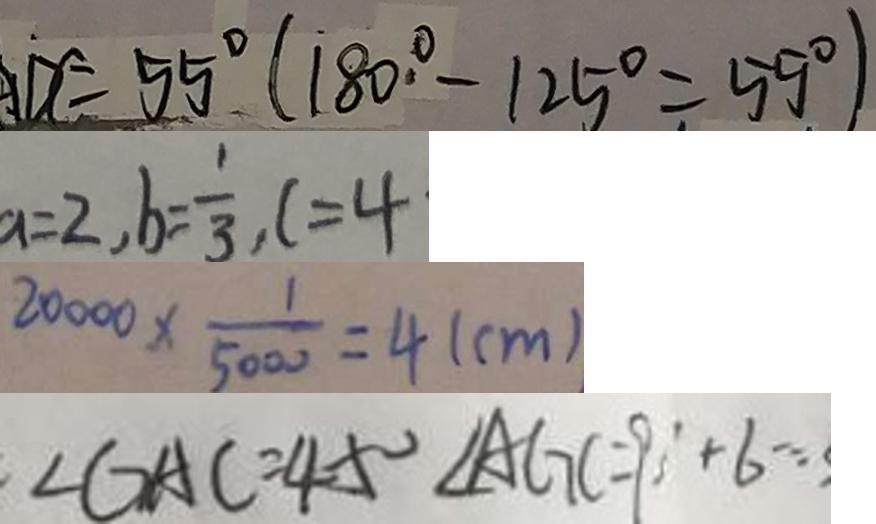Convert formula to latex. <formula><loc_0><loc_0><loc_500><loc_500>A D C = 5 5 ^ { \circ } ( 1 8 0 ^ { \circ } - 1 2 5 ^ { \circ } = 5 5 ^ { \circ } ) 
 a = 2 , b = \frac { 1 } { 3 } , c = 4 
 2 0 0 0 0 \times \frac { 1 } { 5 0 0 0 } = 4 ( c m ) 
 \angle G A C = 4 5 ^ { \circ } \angle A G C = 9 0 ^ { \circ } + 6 =</formula> 